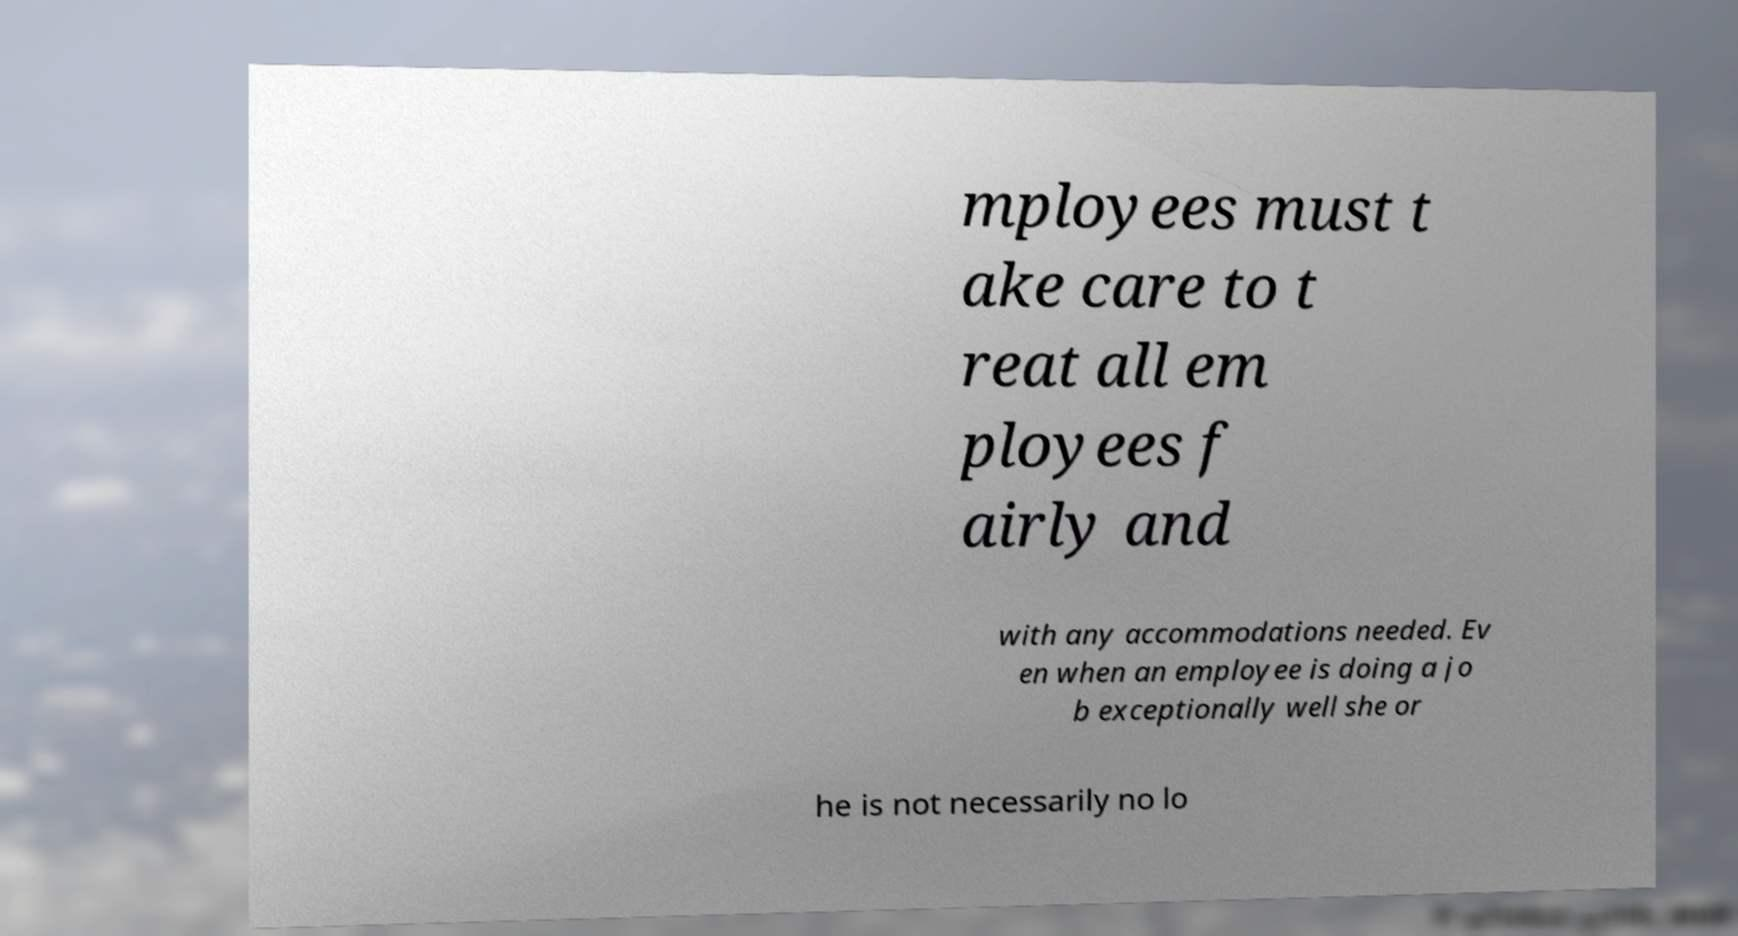Can you accurately transcribe the text from the provided image for me? mployees must t ake care to t reat all em ployees f airly and with any accommodations needed. Ev en when an employee is doing a jo b exceptionally well she or he is not necessarily no lo 